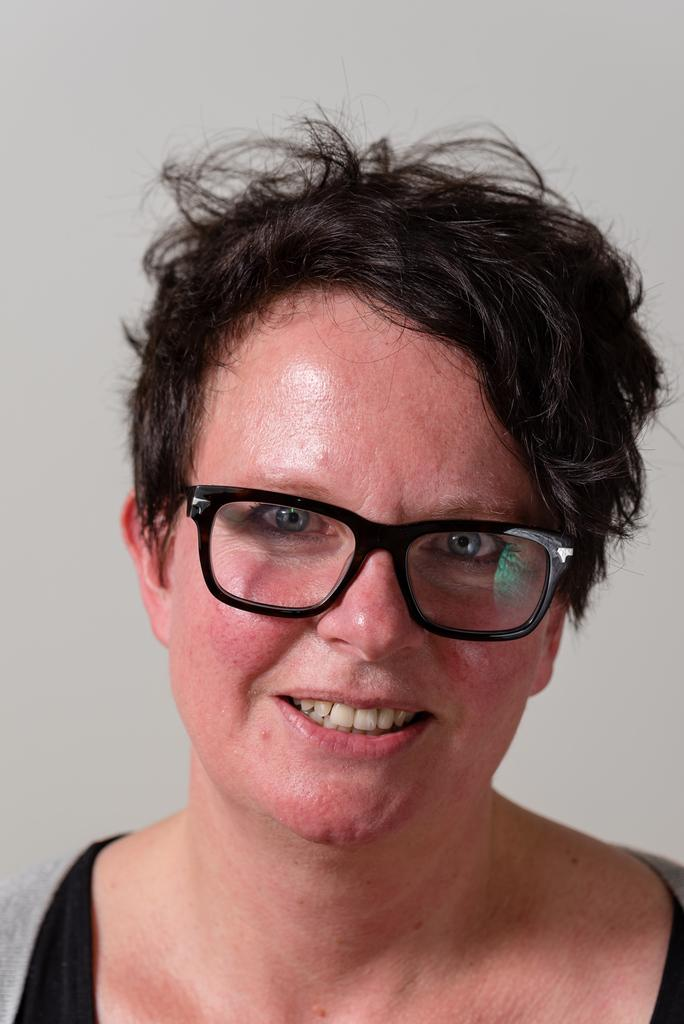What is the main subject of the image? The main subject of the image is a woman. What is the woman's facial expression in the image? The woman is smiling in the image. What accessory is the woman wearing in the image? The woman is wearing spectacles in the image. What can be seen in the background of the image? There is a plane background in the image. What time of day is it in the image, and how does it relate to the cherries? The provided facts do not mention the time of day or cherries, so it is not possible to answer that question. 